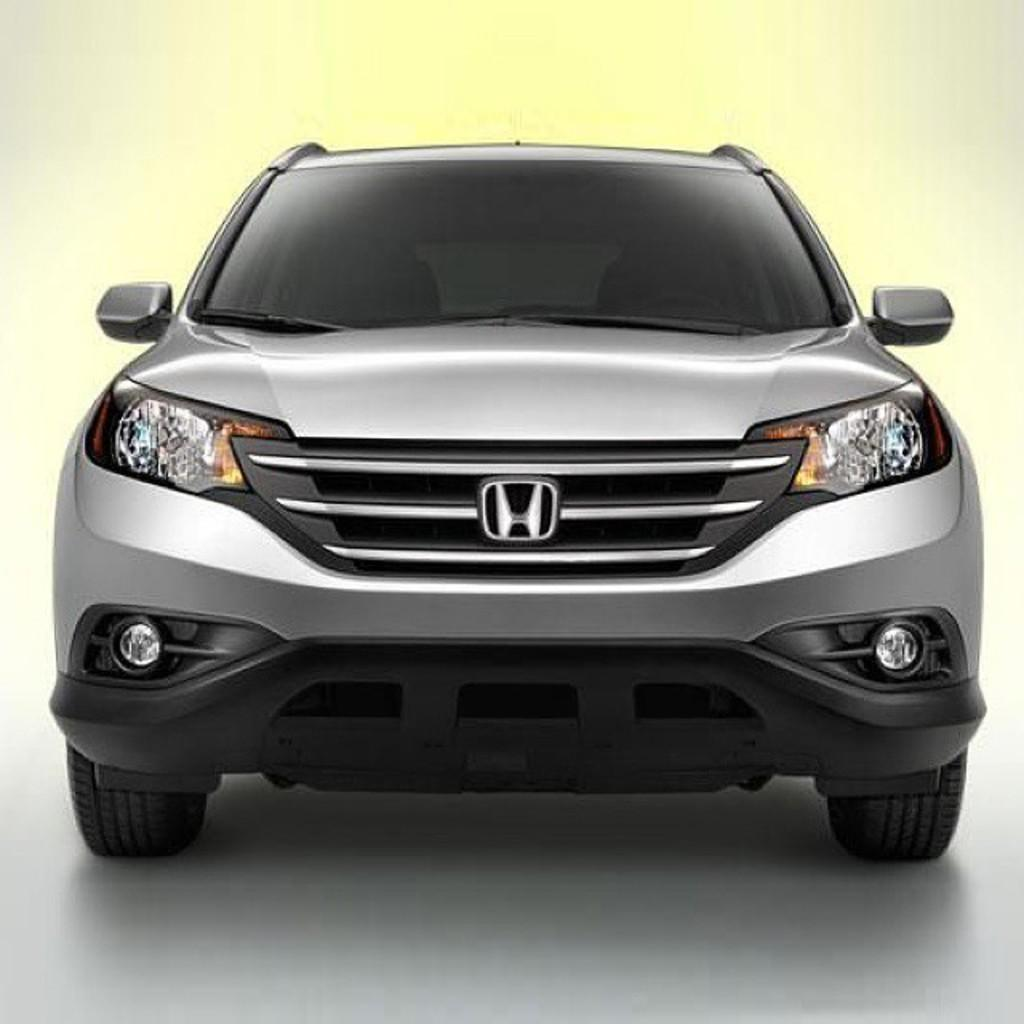What is the main subject of the image? The main subject of the image is a car. Can you describe the car in the image? The car is gray in color. What is the background of the image? There is a floor at the bottom of the image. What type of sign can be seen hanging from the car in the image? There is no sign hanging from the car in the image; it is a gray car with no additional details mentioned. 